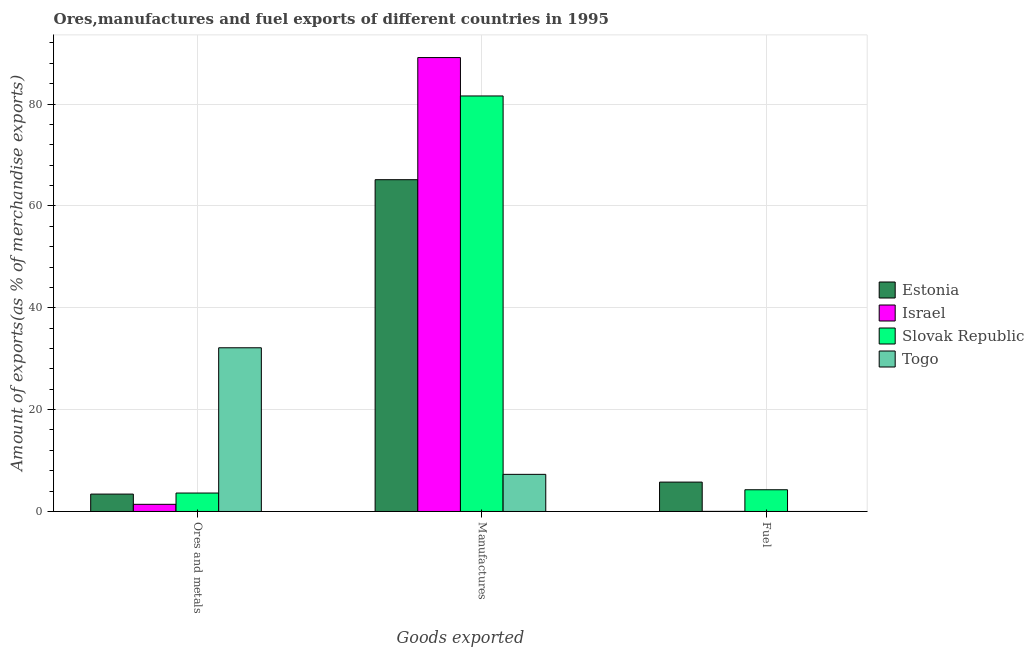How many different coloured bars are there?
Keep it short and to the point. 4. Are the number of bars per tick equal to the number of legend labels?
Your response must be concise. Yes. How many bars are there on the 3rd tick from the right?
Ensure brevity in your answer.  4. What is the label of the 2nd group of bars from the left?
Make the answer very short. Manufactures. What is the percentage of manufactures exports in Slovak Republic?
Your answer should be very brief. 81.59. Across all countries, what is the maximum percentage of manufactures exports?
Give a very brief answer. 89.13. Across all countries, what is the minimum percentage of ores and metals exports?
Keep it short and to the point. 1.41. In which country was the percentage of manufactures exports maximum?
Keep it short and to the point. Israel. In which country was the percentage of fuel exports minimum?
Give a very brief answer. Togo. What is the total percentage of ores and metals exports in the graph?
Keep it short and to the point. 40.59. What is the difference between the percentage of manufactures exports in Togo and that in Estonia?
Make the answer very short. -57.86. What is the difference between the percentage of manufactures exports in Israel and the percentage of fuel exports in Slovak Republic?
Your answer should be very brief. 84.86. What is the average percentage of manufactures exports per country?
Your answer should be compact. 60.79. What is the difference between the percentage of manufactures exports and percentage of fuel exports in Slovak Republic?
Provide a succinct answer. 77.32. What is the ratio of the percentage of ores and metals exports in Estonia to that in Israel?
Keep it short and to the point. 2.43. Is the percentage of manufactures exports in Estonia less than that in Israel?
Your answer should be very brief. Yes. Is the difference between the percentage of fuel exports in Estonia and Israel greater than the difference between the percentage of manufactures exports in Estonia and Israel?
Your response must be concise. Yes. What is the difference between the highest and the second highest percentage of manufactures exports?
Ensure brevity in your answer.  7.54. What is the difference between the highest and the lowest percentage of manufactures exports?
Offer a terse response. 81.84. In how many countries, is the percentage of ores and metals exports greater than the average percentage of ores and metals exports taken over all countries?
Offer a very short reply. 1. What does the 1st bar from the left in Fuel represents?
Make the answer very short. Estonia. What does the 2nd bar from the right in Fuel represents?
Keep it short and to the point. Slovak Republic. Is it the case that in every country, the sum of the percentage of ores and metals exports and percentage of manufactures exports is greater than the percentage of fuel exports?
Give a very brief answer. Yes. How many bars are there?
Your response must be concise. 12. Are all the bars in the graph horizontal?
Offer a terse response. No. What is the difference between two consecutive major ticks on the Y-axis?
Provide a succinct answer. 20. Where does the legend appear in the graph?
Your answer should be very brief. Center right. How are the legend labels stacked?
Your answer should be compact. Vertical. What is the title of the graph?
Keep it short and to the point. Ores,manufactures and fuel exports of different countries in 1995. Does "Burundi" appear as one of the legend labels in the graph?
Provide a short and direct response. No. What is the label or title of the X-axis?
Provide a succinct answer. Goods exported. What is the label or title of the Y-axis?
Your answer should be very brief. Amount of exports(as % of merchandise exports). What is the Amount of exports(as % of merchandise exports) of Estonia in Ores and metals?
Offer a terse response. 3.41. What is the Amount of exports(as % of merchandise exports) in Israel in Ores and metals?
Offer a very short reply. 1.41. What is the Amount of exports(as % of merchandise exports) in Slovak Republic in Ores and metals?
Your answer should be compact. 3.62. What is the Amount of exports(as % of merchandise exports) of Togo in Ores and metals?
Your answer should be compact. 32.14. What is the Amount of exports(as % of merchandise exports) of Estonia in Manufactures?
Provide a succinct answer. 65.15. What is the Amount of exports(as % of merchandise exports) of Israel in Manufactures?
Your answer should be very brief. 89.13. What is the Amount of exports(as % of merchandise exports) in Slovak Republic in Manufactures?
Provide a succinct answer. 81.59. What is the Amount of exports(as % of merchandise exports) in Togo in Manufactures?
Give a very brief answer. 7.29. What is the Amount of exports(as % of merchandise exports) in Estonia in Fuel?
Your answer should be very brief. 5.77. What is the Amount of exports(as % of merchandise exports) in Israel in Fuel?
Make the answer very short. 0.02. What is the Amount of exports(as % of merchandise exports) in Slovak Republic in Fuel?
Your answer should be very brief. 4.27. What is the Amount of exports(as % of merchandise exports) in Togo in Fuel?
Keep it short and to the point. 0. Across all Goods exported, what is the maximum Amount of exports(as % of merchandise exports) of Estonia?
Offer a terse response. 65.15. Across all Goods exported, what is the maximum Amount of exports(as % of merchandise exports) of Israel?
Ensure brevity in your answer.  89.13. Across all Goods exported, what is the maximum Amount of exports(as % of merchandise exports) of Slovak Republic?
Give a very brief answer. 81.59. Across all Goods exported, what is the maximum Amount of exports(as % of merchandise exports) in Togo?
Keep it short and to the point. 32.14. Across all Goods exported, what is the minimum Amount of exports(as % of merchandise exports) of Estonia?
Give a very brief answer. 3.41. Across all Goods exported, what is the minimum Amount of exports(as % of merchandise exports) of Israel?
Ensure brevity in your answer.  0.02. Across all Goods exported, what is the minimum Amount of exports(as % of merchandise exports) of Slovak Republic?
Provide a short and direct response. 3.62. Across all Goods exported, what is the minimum Amount of exports(as % of merchandise exports) of Togo?
Your response must be concise. 0. What is the total Amount of exports(as % of merchandise exports) of Estonia in the graph?
Provide a succinct answer. 74.33. What is the total Amount of exports(as % of merchandise exports) of Israel in the graph?
Offer a very short reply. 90.56. What is the total Amount of exports(as % of merchandise exports) of Slovak Republic in the graph?
Provide a short and direct response. 89.47. What is the total Amount of exports(as % of merchandise exports) in Togo in the graph?
Offer a very short reply. 39.43. What is the difference between the Amount of exports(as % of merchandise exports) of Estonia in Ores and metals and that in Manufactures?
Make the answer very short. -61.73. What is the difference between the Amount of exports(as % of merchandise exports) in Israel in Ores and metals and that in Manufactures?
Keep it short and to the point. -87.72. What is the difference between the Amount of exports(as % of merchandise exports) of Slovak Republic in Ores and metals and that in Manufactures?
Offer a very short reply. -77.97. What is the difference between the Amount of exports(as % of merchandise exports) in Togo in Ores and metals and that in Manufactures?
Make the answer very short. 24.85. What is the difference between the Amount of exports(as % of merchandise exports) in Estonia in Ores and metals and that in Fuel?
Provide a short and direct response. -2.35. What is the difference between the Amount of exports(as % of merchandise exports) of Israel in Ores and metals and that in Fuel?
Provide a succinct answer. 1.38. What is the difference between the Amount of exports(as % of merchandise exports) of Slovak Republic in Ores and metals and that in Fuel?
Your answer should be very brief. -0.65. What is the difference between the Amount of exports(as % of merchandise exports) in Togo in Ores and metals and that in Fuel?
Your response must be concise. 32.14. What is the difference between the Amount of exports(as % of merchandise exports) in Estonia in Manufactures and that in Fuel?
Your response must be concise. 59.38. What is the difference between the Amount of exports(as % of merchandise exports) in Israel in Manufactures and that in Fuel?
Your answer should be very brief. 89.1. What is the difference between the Amount of exports(as % of merchandise exports) in Slovak Republic in Manufactures and that in Fuel?
Keep it short and to the point. 77.32. What is the difference between the Amount of exports(as % of merchandise exports) in Togo in Manufactures and that in Fuel?
Your response must be concise. 7.29. What is the difference between the Amount of exports(as % of merchandise exports) in Estonia in Ores and metals and the Amount of exports(as % of merchandise exports) in Israel in Manufactures?
Your answer should be very brief. -85.71. What is the difference between the Amount of exports(as % of merchandise exports) in Estonia in Ores and metals and the Amount of exports(as % of merchandise exports) in Slovak Republic in Manufactures?
Provide a succinct answer. -78.17. What is the difference between the Amount of exports(as % of merchandise exports) of Estonia in Ores and metals and the Amount of exports(as % of merchandise exports) of Togo in Manufactures?
Offer a very short reply. -3.88. What is the difference between the Amount of exports(as % of merchandise exports) in Israel in Ores and metals and the Amount of exports(as % of merchandise exports) in Slovak Republic in Manufactures?
Offer a terse response. -80.18. What is the difference between the Amount of exports(as % of merchandise exports) of Israel in Ores and metals and the Amount of exports(as % of merchandise exports) of Togo in Manufactures?
Provide a short and direct response. -5.88. What is the difference between the Amount of exports(as % of merchandise exports) in Slovak Republic in Ores and metals and the Amount of exports(as % of merchandise exports) in Togo in Manufactures?
Make the answer very short. -3.67. What is the difference between the Amount of exports(as % of merchandise exports) in Estonia in Ores and metals and the Amount of exports(as % of merchandise exports) in Israel in Fuel?
Provide a succinct answer. 3.39. What is the difference between the Amount of exports(as % of merchandise exports) in Estonia in Ores and metals and the Amount of exports(as % of merchandise exports) in Slovak Republic in Fuel?
Your response must be concise. -0.85. What is the difference between the Amount of exports(as % of merchandise exports) in Estonia in Ores and metals and the Amount of exports(as % of merchandise exports) in Togo in Fuel?
Provide a succinct answer. 3.41. What is the difference between the Amount of exports(as % of merchandise exports) in Israel in Ores and metals and the Amount of exports(as % of merchandise exports) in Slovak Republic in Fuel?
Provide a short and direct response. -2.86. What is the difference between the Amount of exports(as % of merchandise exports) in Israel in Ores and metals and the Amount of exports(as % of merchandise exports) in Togo in Fuel?
Ensure brevity in your answer.  1.41. What is the difference between the Amount of exports(as % of merchandise exports) in Slovak Republic in Ores and metals and the Amount of exports(as % of merchandise exports) in Togo in Fuel?
Offer a very short reply. 3.62. What is the difference between the Amount of exports(as % of merchandise exports) of Estonia in Manufactures and the Amount of exports(as % of merchandise exports) of Israel in Fuel?
Provide a succinct answer. 65.12. What is the difference between the Amount of exports(as % of merchandise exports) in Estonia in Manufactures and the Amount of exports(as % of merchandise exports) in Slovak Republic in Fuel?
Your answer should be compact. 60.88. What is the difference between the Amount of exports(as % of merchandise exports) in Estonia in Manufactures and the Amount of exports(as % of merchandise exports) in Togo in Fuel?
Provide a succinct answer. 65.15. What is the difference between the Amount of exports(as % of merchandise exports) of Israel in Manufactures and the Amount of exports(as % of merchandise exports) of Slovak Republic in Fuel?
Offer a terse response. 84.86. What is the difference between the Amount of exports(as % of merchandise exports) of Israel in Manufactures and the Amount of exports(as % of merchandise exports) of Togo in Fuel?
Ensure brevity in your answer.  89.13. What is the difference between the Amount of exports(as % of merchandise exports) of Slovak Republic in Manufactures and the Amount of exports(as % of merchandise exports) of Togo in Fuel?
Offer a terse response. 81.59. What is the average Amount of exports(as % of merchandise exports) of Estonia per Goods exported?
Offer a very short reply. 24.78. What is the average Amount of exports(as % of merchandise exports) of Israel per Goods exported?
Your response must be concise. 30.19. What is the average Amount of exports(as % of merchandise exports) in Slovak Republic per Goods exported?
Provide a succinct answer. 29.82. What is the average Amount of exports(as % of merchandise exports) of Togo per Goods exported?
Provide a succinct answer. 13.14. What is the difference between the Amount of exports(as % of merchandise exports) of Estonia and Amount of exports(as % of merchandise exports) of Israel in Ores and metals?
Your response must be concise. 2.01. What is the difference between the Amount of exports(as % of merchandise exports) in Estonia and Amount of exports(as % of merchandise exports) in Slovak Republic in Ores and metals?
Provide a succinct answer. -0.21. What is the difference between the Amount of exports(as % of merchandise exports) of Estonia and Amount of exports(as % of merchandise exports) of Togo in Ores and metals?
Keep it short and to the point. -28.73. What is the difference between the Amount of exports(as % of merchandise exports) of Israel and Amount of exports(as % of merchandise exports) of Slovak Republic in Ores and metals?
Provide a succinct answer. -2.22. What is the difference between the Amount of exports(as % of merchandise exports) of Israel and Amount of exports(as % of merchandise exports) of Togo in Ores and metals?
Your answer should be very brief. -30.74. What is the difference between the Amount of exports(as % of merchandise exports) in Slovak Republic and Amount of exports(as % of merchandise exports) in Togo in Ores and metals?
Your answer should be very brief. -28.52. What is the difference between the Amount of exports(as % of merchandise exports) in Estonia and Amount of exports(as % of merchandise exports) in Israel in Manufactures?
Provide a succinct answer. -23.98. What is the difference between the Amount of exports(as % of merchandise exports) of Estonia and Amount of exports(as % of merchandise exports) of Slovak Republic in Manufactures?
Provide a short and direct response. -16.44. What is the difference between the Amount of exports(as % of merchandise exports) in Estonia and Amount of exports(as % of merchandise exports) in Togo in Manufactures?
Your answer should be very brief. 57.86. What is the difference between the Amount of exports(as % of merchandise exports) in Israel and Amount of exports(as % of merchandise exports) in Slovak Republic in Manufactures?
Your answer should be very brief. 7.54. What is the difference between the Amount of exports(as % of merchandise exports) in Israel and Amount of exports(as % of merchandise exports) in Togo in Manufactures?
Your response must be concise. 81.84. What is the difference between the Amount of exports(as % of merchandise exports) in Slovak Republic and Amount of exports(as % of merchandise exports) in Togo in Manufactures?
Ensure brevity in your answer.  74.3. What is the difference between the Amount of exports(as % of merchandise exports) in Estonia and Amount of exports(as % of merchandise exports) in Israel in Fuel?
Your response must be concise. 5.74. What is the difference between the Amount of exports(as % of merchandise exports) of Estonia and Amount of exports(as % of merchandise exports) of Slovak Republic in Fuel?
Offer a very short reply. 1.5. What is the difference between the Amount of exports(as % of merchandise exports) in Estonia and Amount of exports(as % of merchandise exports) in Togo in Fuel?
Offer a terse response. 5.77. What is the difference between the Amount of exports(as % of merchandise exports) of Israel and Amount of exports(as % of merchandise exports) of Slovak Republic in Fuel?
Ensure brevity in your answer.  -4.24. What is the difference between the Amount of exports(as % of merchandise exports) in Israel and Amount of exports(as % of merchandise exports) in Togo in Fuel?
Make the answer very short. 0.02. What is the difference between the Amount of exports(as % of merchandise exports) of Slovak Republic and Amount of exports(as % of merchandise exports) of Togo in Fuel?
Provide a short and direct response. 4.27. What is the ratio of the Amount of exports(as % of merchandise exports) of Estonia in Ores and metals to that in Manufactures?
Your answer should be very brief. 0.05. What is the ratio of the Amount of exports(as % of merchandise exports) of Israel in Ores and metals to that in Manufactures?
Your response must be concise. 0.02. What is the ratio of the Amount of exports(as % of merchandise exports) in Slovak Republic in Ores and metals to that in Manufactures?
Your answer should be very brief. 0.04. What is the ratio of the Amount of exports(as % of merchandise exports) in Togo in Ores and metals to that in Manufactures?
Provide a succinct answer. 4.41. What is the ratio of the Amount of exports(as % of merchandise exports) of Estonia in Ores and metals to that in Fuel?
Keep it short and to the point. 0.59. What is the ratio of the Amount of exports(as % of merchandise exports) of Israel in Ores and metals to that in Fuel?
Ensure brevity in your answer.  57.99. What is the ratio of the Amount of exports(as % of merchandise exports) of Slovak Republic in Ores and metals to that in Fuel?
Ensure brevity in your answer.  0.85. What is the ratio of the Amount of exports(as % of merchandise exports) in Togo in Ores and metals to that in Fuel?
Give a very brief answer. 1.53e+05. What is the ratio of the Amount of exports(as % of merchandise exports) of Estonia in Manufactures to that in Fuel?
Ensure brevity in your answer.  11.29. What is the ratio of the Amount of exports(as % of merchandise exports) of Israel in Manufactures to that in Fuel?
Your answer should be very brief. 3676.86. What is the ratio of the Amount of exports(as % of merchandise exports) in Slovak Republic in Manufactures to that in Fuel?
Give a very brief answer. 19.12. What is the ratio of the Amount of exports(as % of merchandise exports) of Togo in Manufactures to that in Fuel?
Offer a terse response. 3.47e+04. What is the difference between the highest and the second highest Amount of exports(as % of merchandise exports) in Estonia?
Provide a succinct answer. 59.38. What is the difference between the highest and the second highest Amount of exports(as % of merchandise exports) of Israel?
Give a very brief answer. 87.72. What is the difference between the highest and the second highest Amount of exports(as % of merchandise exports) in Slovak Republic?
Offer a terse response. 77.32. What is the difference between the highest and the second highest Amount of exports(as % of merchandise exports) of Togo?
Make the answer very short. 24.85. What is the difference between the highest and the lowest Amount of exports(as % of merchandise exports) of Estonia?
Make the answer very short. 61.73. What is the difference between the highest and the lowest Amount of exports(as % of merchandise exports) in Israel?
Provide a succinct answer. 89.1. What is the difference between the highest and the lowest Amount of exports(as % of merchandise exports) of Slovak Republic?
Give a very brief answer. 77.97. What is the difference between the highest and the lowest Amount of exports(as % of merchandise exports) of Togo?
Keep it short and to the point. 32.14. 